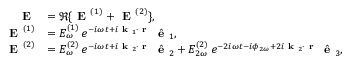Convert formula to latex. <formula><loc_0><loc_0><loc_500><loc_500>\begin{array} { r l } { E } & { = \Re \{ E ^ { ( 1 ) } + E ^ { ( 2 ) } \} , } \\ { E ^ { ( 1 ) } } & { = E _ { \omega } ^ { ( 1 ) } \, e ^ { - i \omega t + i k _ { 1 } \cdot r } \, \hat { e } _ { 1 } , } \\ { E ^ { ( 2 ) } } & { = E _ { \omega } ^ { ( 2 ) } \, e ^ { - i \omega t + i k _ { 2 } \cdot r } \, \hat { e } _ { 2 } + E _ { 2 \omega } ^ { ( 2 ) } \, e ^ { - 2 i \omega t - i \phi _ { 2 \omega } + 2 i k _ { 2 } \cdot r } \, \hat { e } _ { 3 } , } \end{array}</formula> 